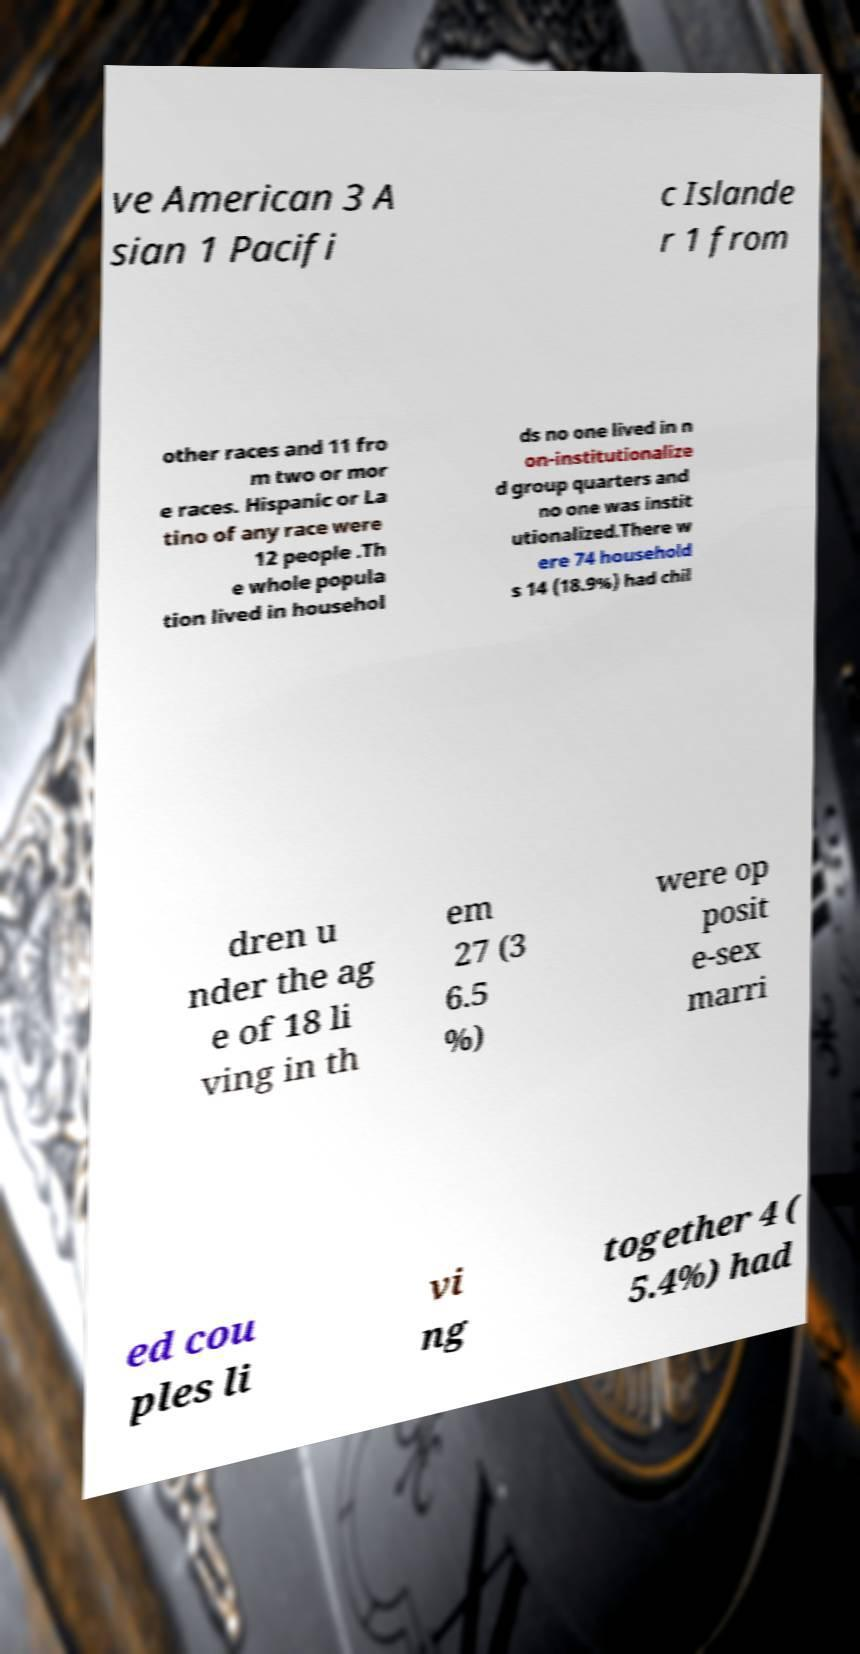Can you accurately transcribe the text from the provided image for me? ve American 3 A sian 1 Pacifi c Islande r 1 from other races and 11 fro m two or mor e races. Hispanic or La tino of any race were 12 people .Th e whole popula tion lived in househol ds no one lived in n on-institutionalize d group quarters and no one was instit utionalized.There w ere 74 household s 14 (18.9%) had chil dren u nder the ag e of 18 li ving in th em 27 (3 6.5 %) were op posit e-sex marri ed cou ples li vi ng together 4 ( 5.4%) had 